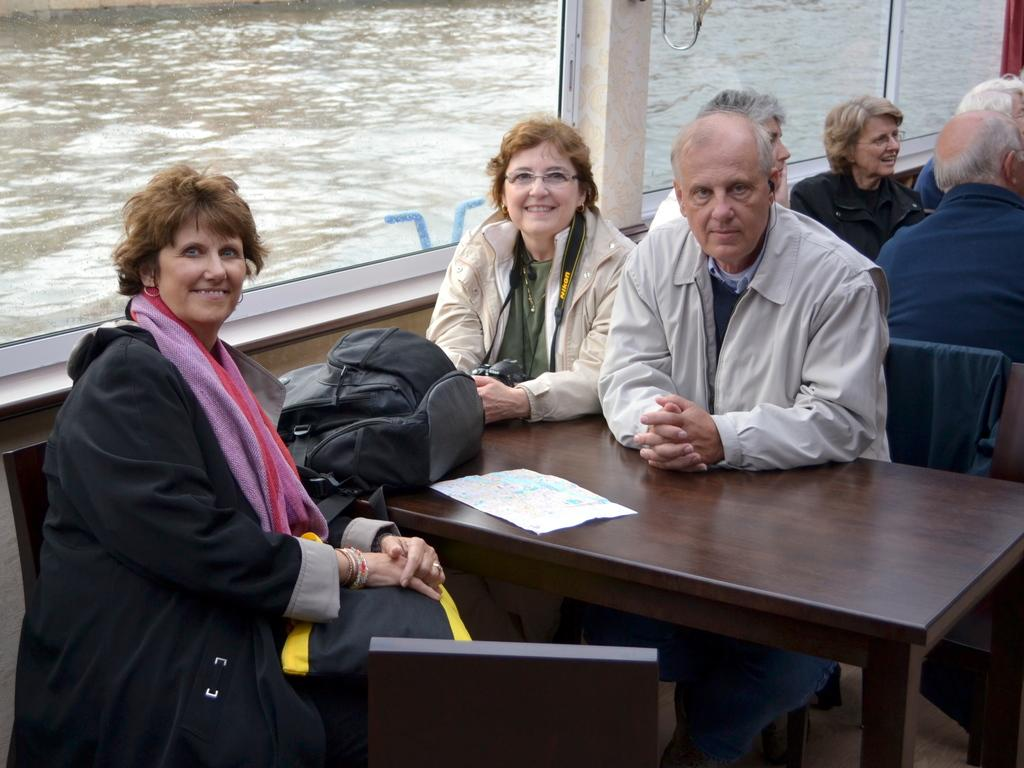What is happening in the image involving a group of people? The people in the image are seated on chairs. Can you describe the setting where the people are seated? There is a backpack on a table in the image, which suggests a casual or informal setting. What can be seen through the window in the image? Water is visible in a canal through a window in the image. What type of rings can be seen on the celery plants in the image? There are no rings or celery plants present in the image. 